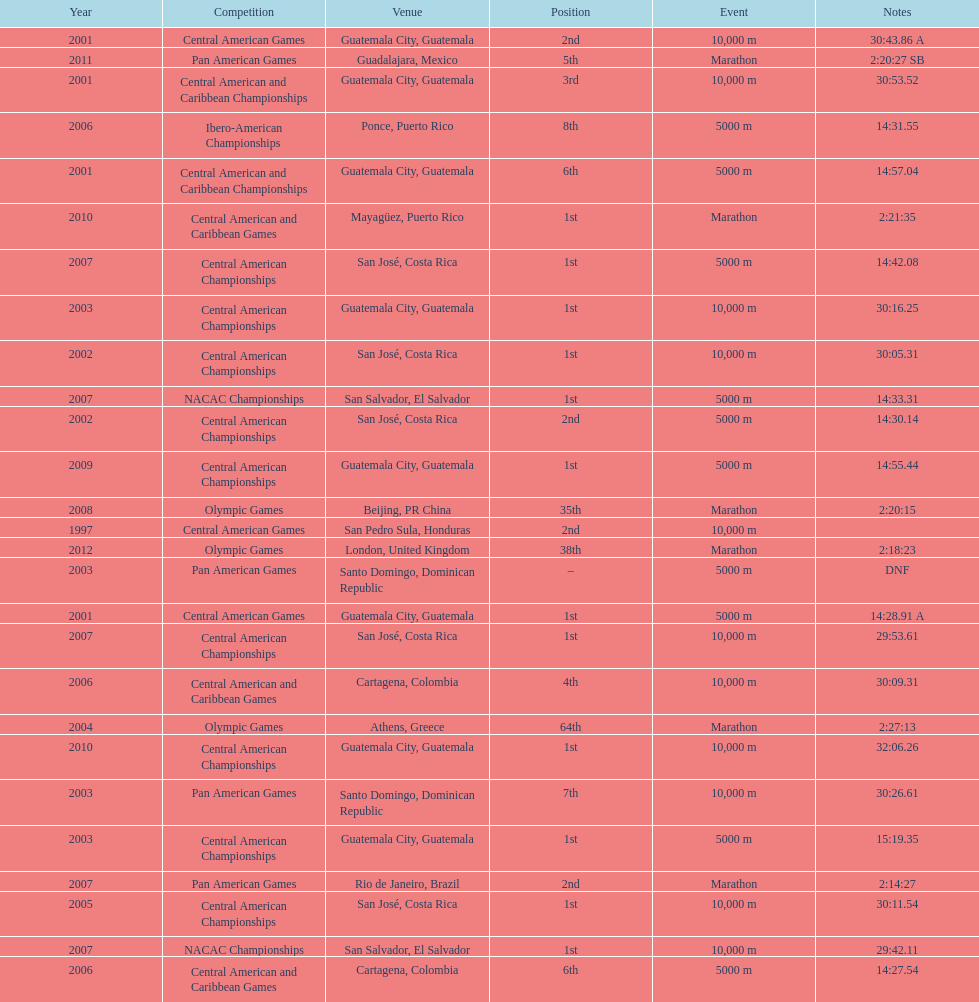Which event is listed more between the 10,000m and the 5000m? 10,000 m. 